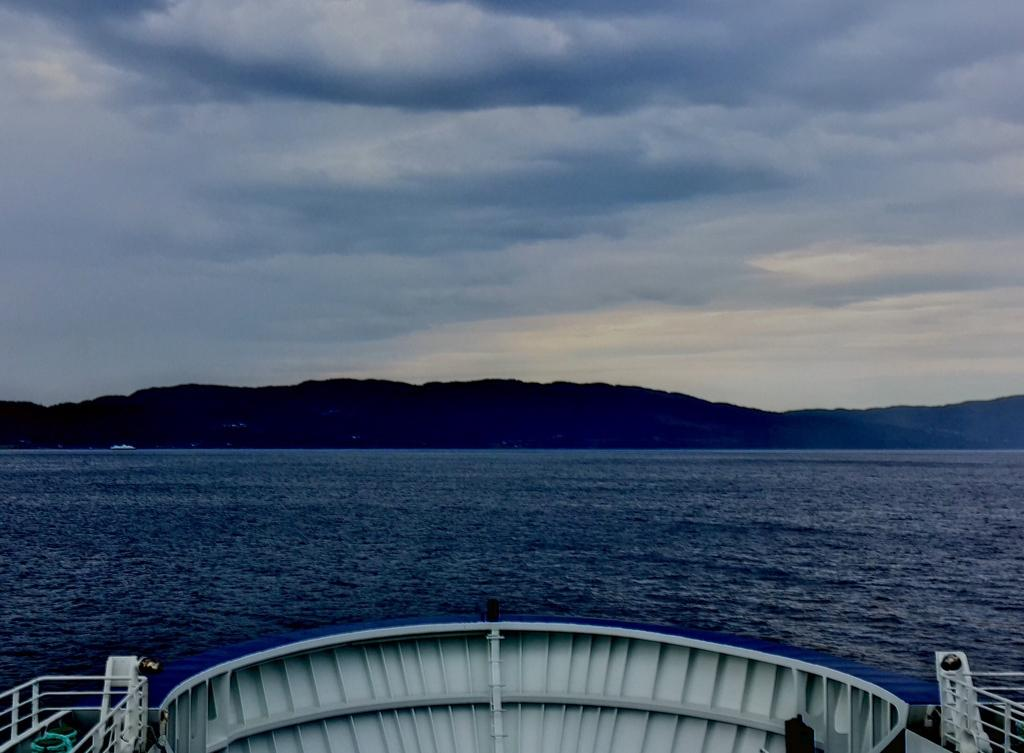What type of objects are located at the bottom of the image? There are metal rods at the bottom of the image. What can be seen in the background of the image? Water, hills, and clouds are present in the background of the image. What type of coal can be seen cracking in the image? There is no coal present in the image, and therefore no cracking can be observed. How many beds are visible in the image? There are no beds present in the image. 